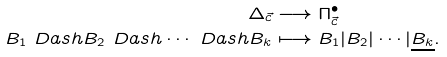Convert formula to latex. <formula><loc_0><loc_0><loc_500><loc_500>\Delta _ { \vec { c } } & \longrightarrow \Pi _ { \vec { c } } ^ { \bullet } \\ B _ { 1 } \ D a s h B _ { 2 } \ D a s h \cdots \ D a s h B _ { k } & \longmapsto B _ { 1 } | B _ { 2 } | \cdots | \underline { B _ { k } } .</formula> 